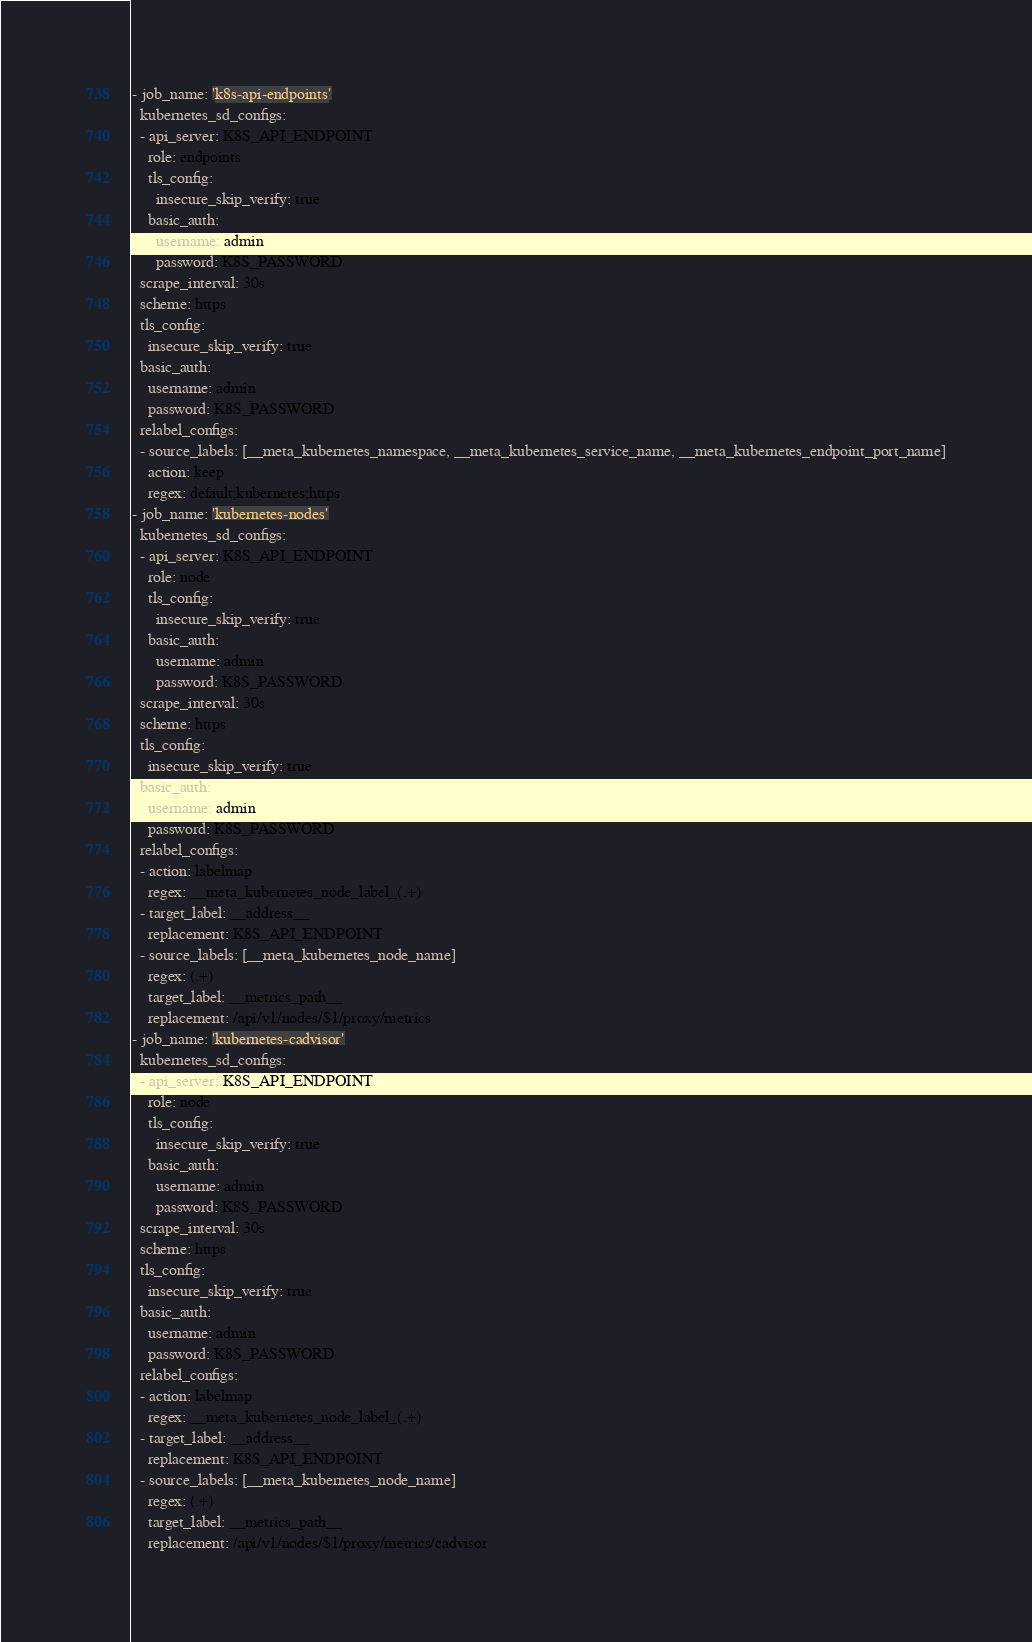<code> <loc_0><loc_0><loc_500><loc_500><_YAML_>- job_name: 'k8s-api-endpoints'
  kubernetes_sd_configs:
  - api_server: K8S_API_ENDPOINT
    role: endpoints
    tls_config:
      insecure_skip_verify: true
    basic_auth:
      username: admin
      password: K8S_PASSWORD
  scrape_interval: 30s
  scheme: https
  tls_config:
    insecure_skip_verify: true
  basic_auth:
    username: admin
    password: K8S_PASSWORD
  relabel_configs:
  - source_labels: [__meta_kubernetes_namespace, __meta_kubernetes_service_name, __meta_kubernetes_endpoint_port_name]
    action: keep
    regex: default;kubernetes;https
- job_name: 'kubernetes-nodes'
  kubernetes_sd_configs:
  - api_server: K8S_API_ENDPOINT
    role: node
    tls_config:
      insecure_skip_verify: true
    basic_auth:
      username: admin
      password: K8S_PASSWORD
  scrape_interval: 30s
  scheme: https
  tls_config:
    insecure_skip_verify: true
  basic_auth:
    username: admin
    password: K8S_PASSWORD
  relabel_configs:
  - action: labelmap
    regex: __meta_kubernetes_node_label_(.+)
  - target_label: __address__
    replacement: K8S_API_ENDPOINT
  - source_labels: [__meta_kubernetes_node_name]
    regex: (.+)
    target_label: __metrics_path__
    replacement: /api/v1/nodes/$1/proxy/metrics
- job_name: 'kubernetes-cadvisor'
  kubernetes_sd_configs:
  - api_server: K8S_API_ENDPOINT
    role: node
    tls_config:
      insecure_skip_verify: true
    basic_auth:
      username: admin
      password: K8S_PASSWORD
  scrape_interval: 30s
  scheme: https
  tls_config:
    insecure_skip_verify: true
  basic_auth:
    username: admin
    password: K8S_PASSWORD
  relabel_configs:
  - action: labelmap
    regex: __meta_kubernetes_node_label_(.+)
  - target_label: __address__
    replacement: K8S_API_ENDPOINT
  - source_labels: [__meta_kubernetes_node_name]
    regex: (.+)
    target_label: __metrics_path__
    replacement: /api/v1/nodes/$1/proxy/metrics/cadvisor
</code> 